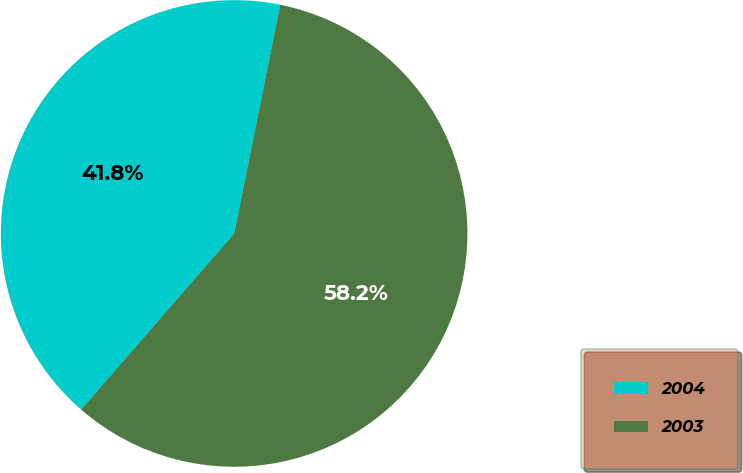Convert chart. <chart><loc_0><loc_0><loc_500><loc_500><pie_chart><fcel>2004<fcel>2003<nl><fcel>41.77%<fcel>58.23%<nl></chart> 